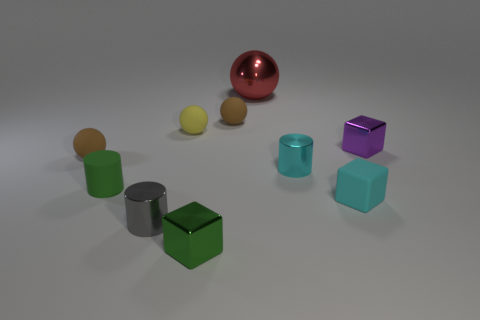Is there anything else that has the same material as the red thing?
Offer a terse response. Yes. There is a yellow rubber ball; is its size the same as the metal cube to the left of the small cyan matte block?
Provide a short and direct response. Yes. What number of other objects are there of the same color as the large shiny sphere?
Give a very brief answer. 0. There is a cyan cube; are there any small green blocks right of it?
Offer a terse response. No. What number of things are either red objects or cyan matte objects that are right of the yellow matte object?
Ensure brevity in your answer.  2. Is there a large metal object to the left of the tiny shiny block that is in front of the tiny purple metal thing?
Provide a short and direct response. No. The brown matte object left of the metallic thing on the left side of the metal cube left of the purple metallic thing is what shape?
Provide a succinct answer. Sphere. There is a shiny object that is behind the green cylinder and left of the tiny cyan cylinder; what is its color?
Your answer should be compact. Red. The cyan thing that is left of the cyan cube has what shape?
Offer a very short reply. Cylinder. The tiny cyan thing that is the same material as the gray cylinder is what shape?
Your answer should be compact. Cylinder. 